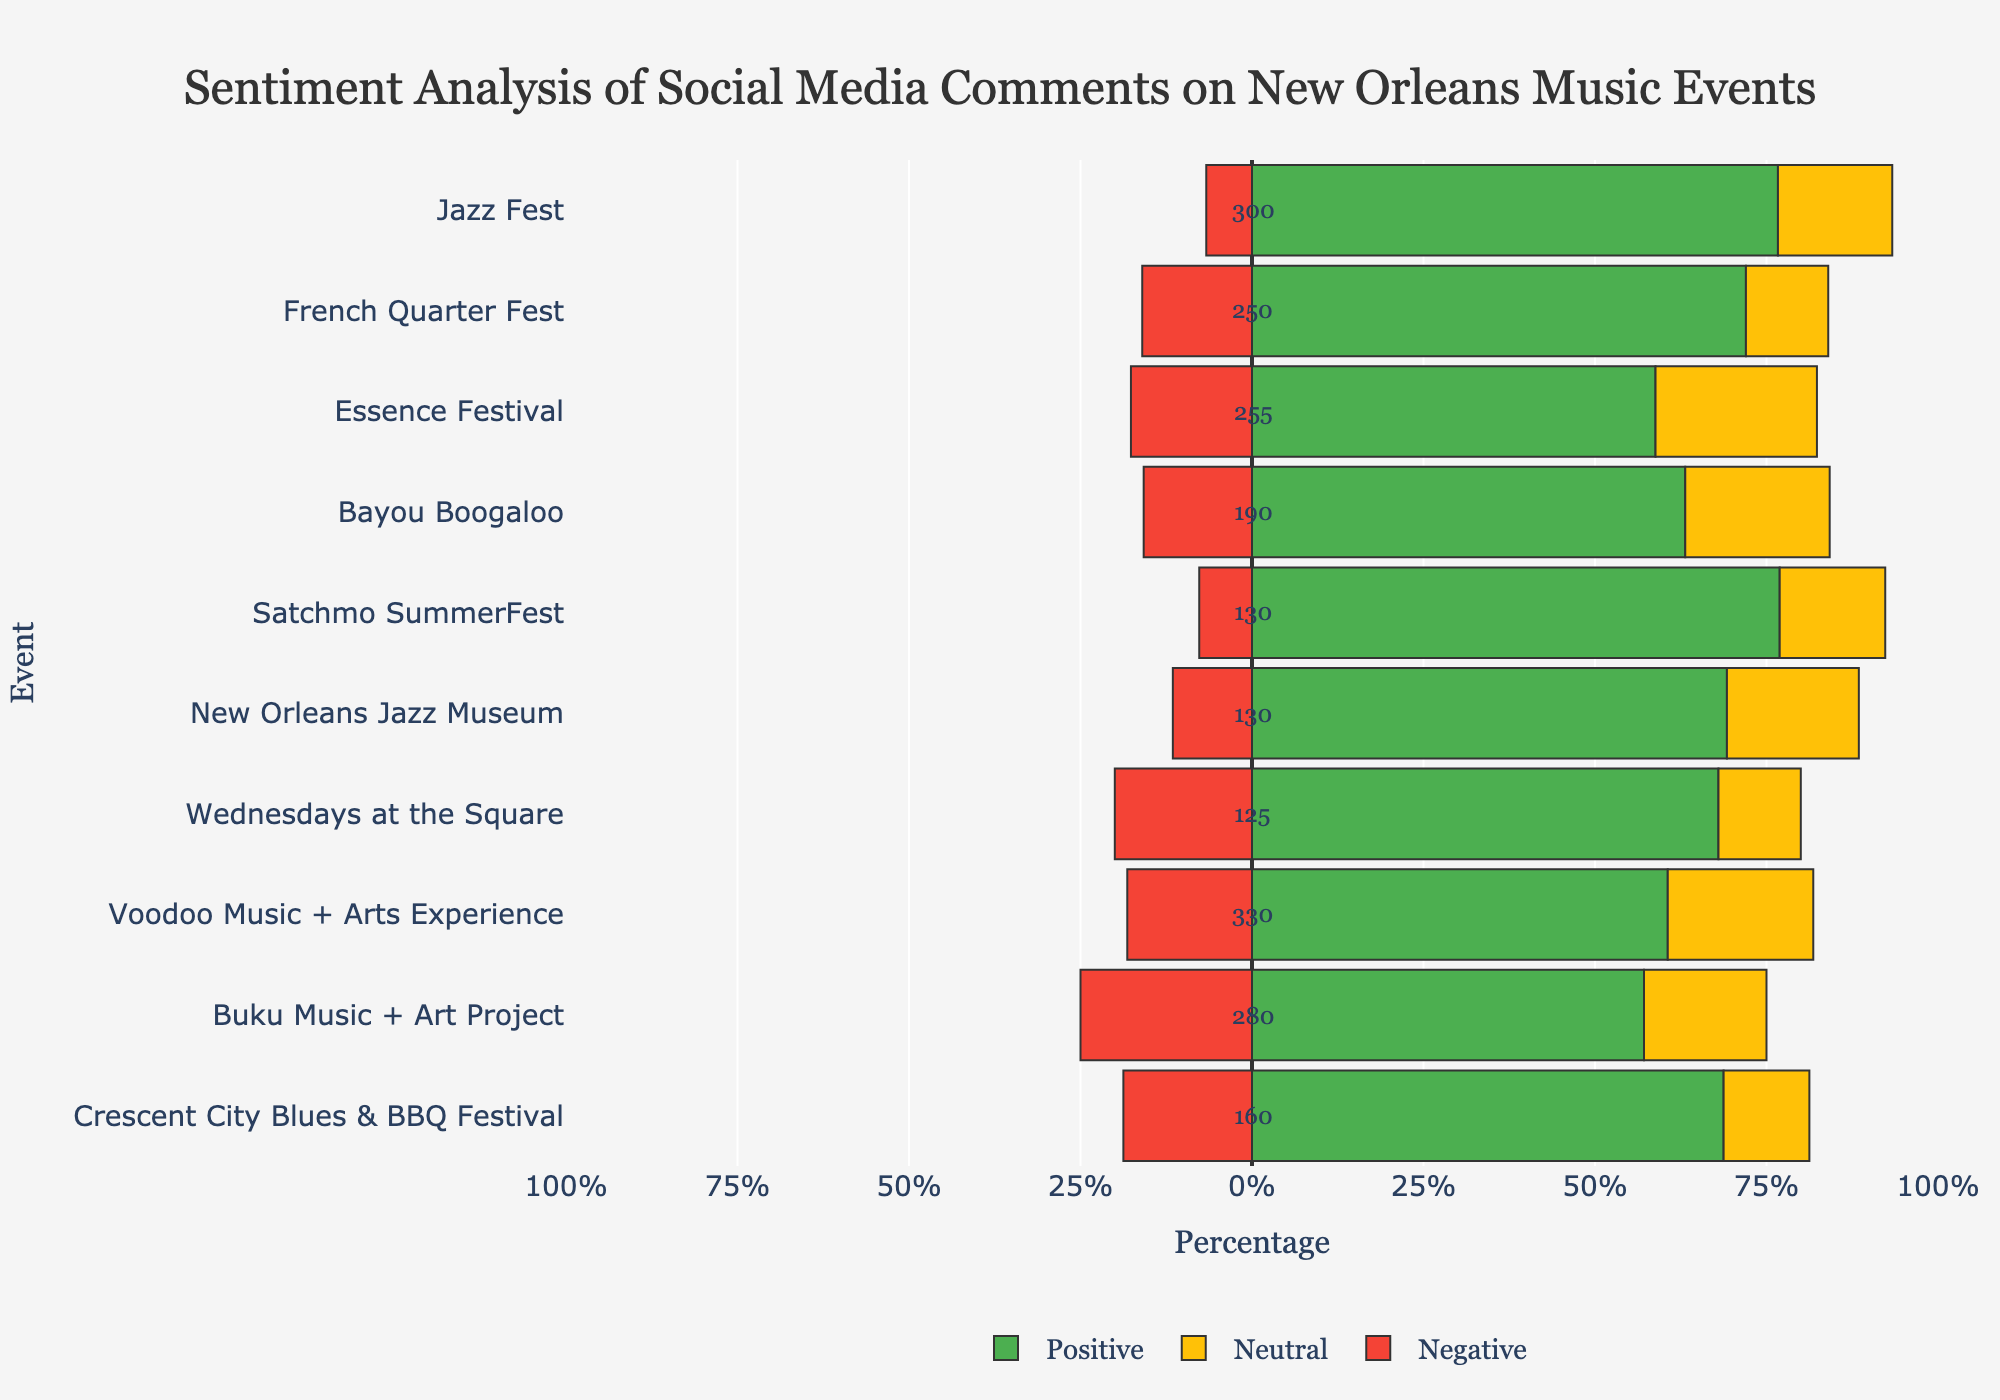Which event has the highest percentage of positive comments? The event with the highest green bar represents the highest percentage of positive comments. Here, the Jazz Fest has the longest green bar.
Answer: Jazz Fest Which event has the lowest percentage of negative comments? The event with the shortest red bar represents the lowest percentage of negative comments. Here, Satchmo SummerFest has the shortest red bar.
Answer: Satchmo SummerFest Do any events have a neutral percentage above 30%? Look for the events with yellow bars exceeding 30% of the total width. Essence Festival and Voodoo Music + Arts Experience both have yellow bars above 30%.
Answer: Yes Which events have more negative comments than neutral comments? Compare the lengths of the red and yellow bars for each event. Voodoo Music + Arts Experience and Buku Music + Art Project, both have longer red bars compared to yellow bars.
Answer: Voodoo Music + Arts Experience, Buku Music + Art Project What is the total number of comments for Jazz Fest? The annotation next to Jazz Fest shows the total count of comments. Here, it is annotated as 300.
Answer: 300 Which event has the closest percentage of positive and negative comments? Calculate the difference between the positive and negative percentages for each event. The event with the smallest difference is Satchmo SummerFest (approximately 78.3% positive and 8.7% negative).
Answer: Satchmo SummerFest Which event has more than 50% comments marked as positive? Look for events where the green bar extends beyond the 50% mark. Jazz Fest, French Quarter Fest, and Bayou Boogaloo all have positive percentages above 50%.
Answer: Jazz Fest, French Quarter Fest, Bayou Boogaloo Which event has the largest disparity between positive and negative comments? Find the event with the largest visual gap between the green and red bars. Jazz Fest has the largest difference, with over 76.7% positive and 6.7% negative.
Answer: Jazz Fest Which event received the fewest total comments? Check the annotations for the total number of comments. The event with the smallest number is Satchmo SummerFest with 130 comments.
Answer: Satchmo SummerFest 